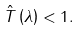Convert formula to latex. <formula><loc_0><loc_0><loc_500><loc_500>\hat { T } \left ( \lambda \right ) < 1 .</formula> 